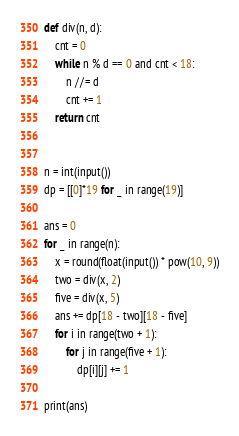<code> <loc_0><loc_0><loc_500><loc_500><_Python_>def div(n, d):
    cnt = 0
    while n % d == 0 and cnt < 18:
        n //= d
        cnt += 1
    return cnt


n = int(input())
dp = [[0]*19 for _ in range(19)]

ans = 0
for _ in range(n):
    x = round(float(input()) * pow(10, 9))
    two = div(x, 2)
    five = div(x, 5)
    ans += dp[18 - two][18 - five]
    for i in range(two + 1):
        for j in range(five + 1):
            dp[i][j] += 1

print(ans)</code> 